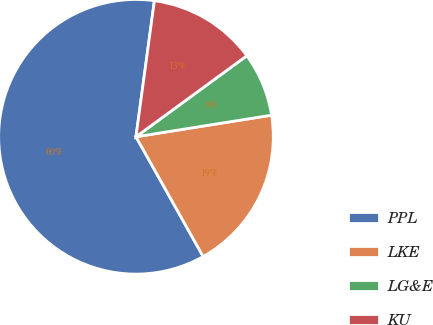<chart> <loc_0><loc_0><loc_500><loc_500><pie_chart><fcel>PPL<fcel>LKE<fcel>LG&E<fcel>KU<nl><fcel>60.28%<fcel>19.38%<fcel>7.53%<fcel>12.81%<nl></chart> 